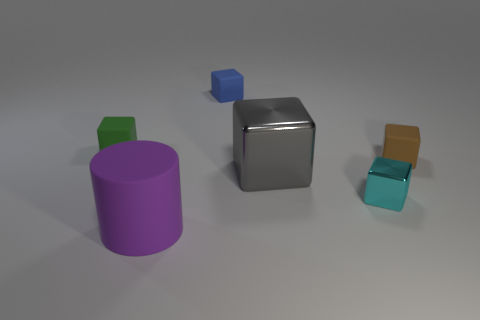Subtract all big gray cubes. How many cubes are left? 4 Subtract all purple blocks. Subtract all green cylinders. How many blocks are left? 5 Add 2 purple cylinders. How many objects exist? 8 Subtract all cylinders. How many objects are left? 5 Add 6 gray metal objects. How many gray metal objects are left? 7 Add 5 small red spheres. How many small red spheres exist? 5 Subtract 1 blue blocks. How many objects are left? 5 Subtract all big cyan cylinders. Subtract all brown rubber cubes. How many objects are left? 5 